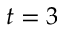<formula> <loc_0><loc_0><loc_500><loc_500>t = 3</formula> 